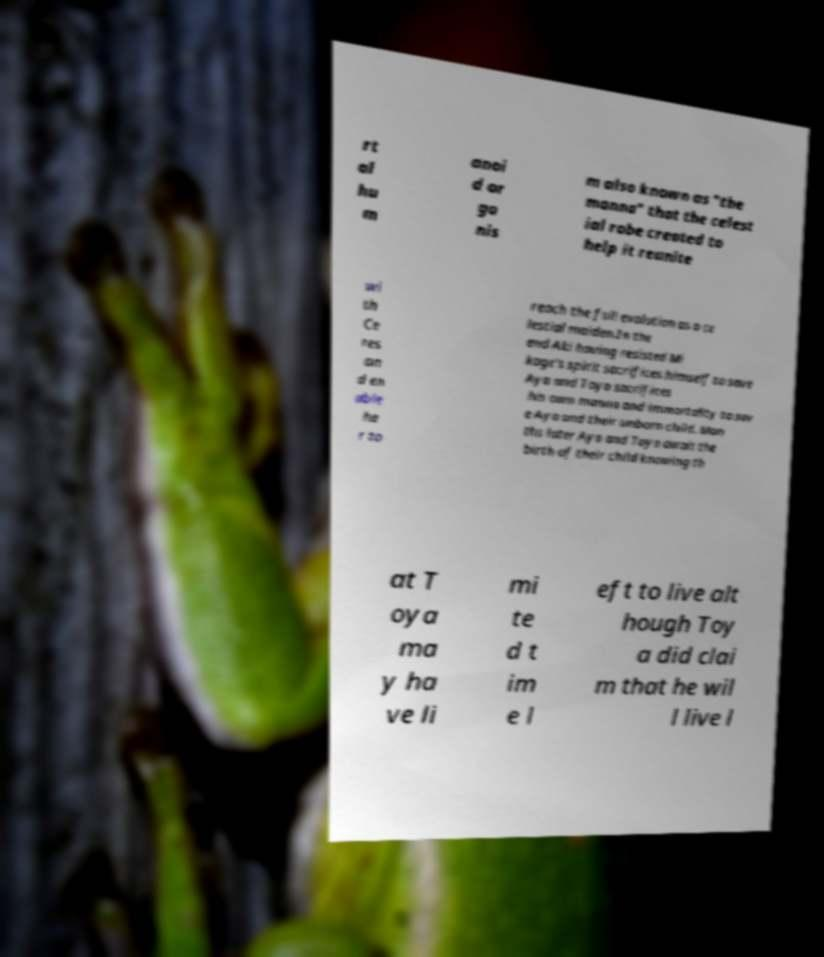Could you assist in decoding the text presented in this image and type it out clearly? rt al hu m anoi d or ga nis m also known as "the manna" that the celest ial robe created to help it reunite wi th Ce res an d en able he r to reach the full evolution as a ce lestial maiden.In the end Aki having resisted Mi kage's spirit sacrifices himself to save Aya and Toya sacrifices his own manna and immortality to sav e Aya and their unborn child. Mon ths later Aya and Toya await the birth of their child knowing th at T oya ma y ha ve li mi te d t im e l eft to live alt hough Toy a did clai m that he wil l live l 